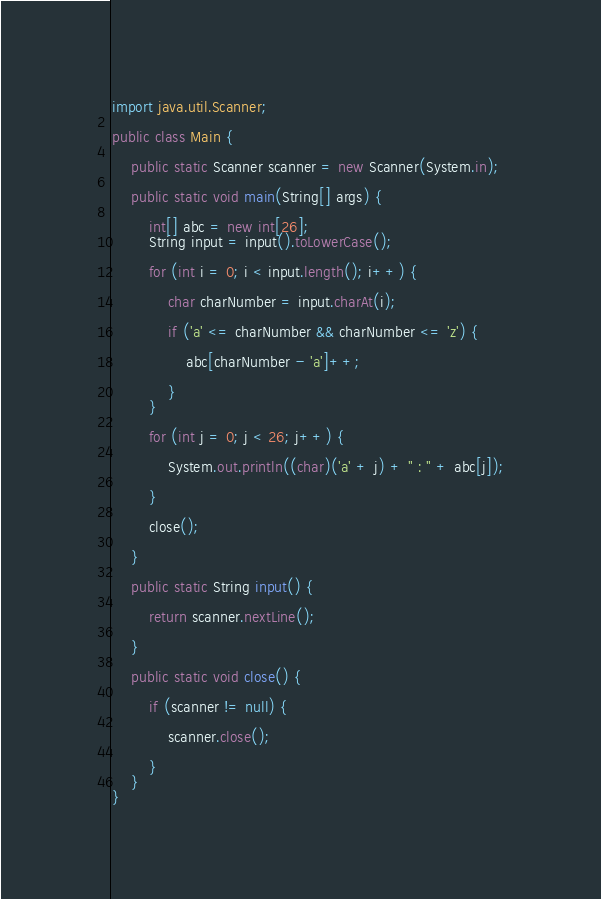<code> <loc_0><loc_0><loc_500><loc_500><_Java_>import java.util.Scanner;

public class Main {

	public static Scanner scanner = new Scanner(System.in);

	public static void main(String[] args) {

		int[] abc = new int[26];
		String input = input().toLowerCase();

		for (int i = 0; i < input.length(); i++) {

			char charNumber = input.charAt(i);

			if ('a' <= charNumber && charNumber <= 'z') {

				abc[charNumber - 'a']++;

			}
		}

		for (int j = 0; j < 26; j++) {

			System.out.println((char)('a' + j) + " : " + abc[j]);

		}

		close();

	}

	public static String input() {

		return scanner.nextLine();

	}

	public static void close() {

		if (scanner != null) {

			scanner.close();

		}
	}
}</code> 